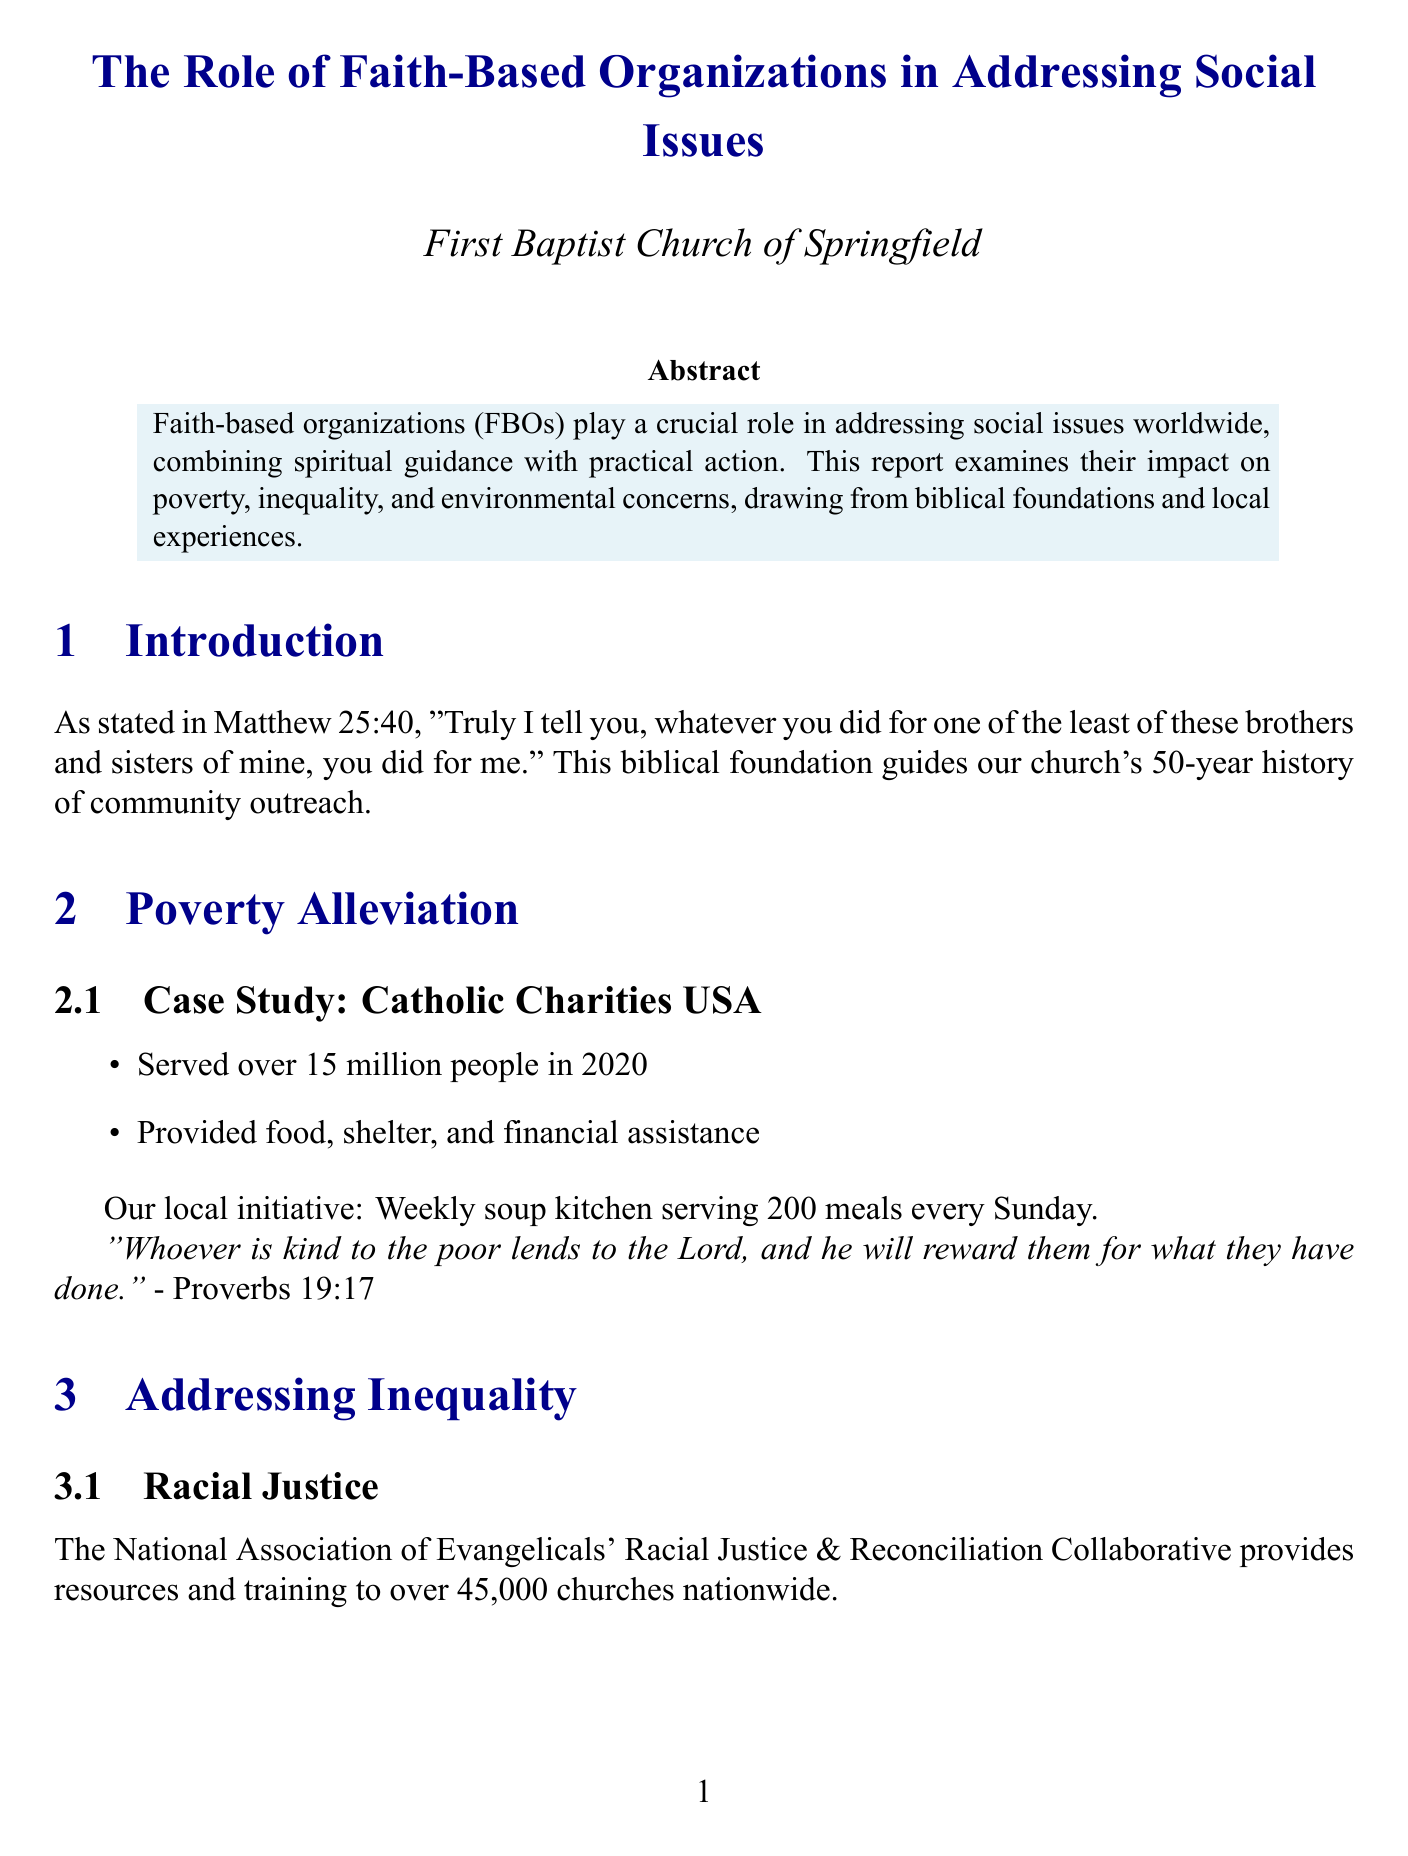What is the biblical foundation for addressing social issues? The document quotes Matthew 25:40, emphasizing the importance of helping those in need.
Answer: Matthew 25:40 How many people did Catholic Charities USA serve in 2020? The document states that they served over 15 million people in that year.
Answer: 15 million What is the local initiative mentioned for poverty alleviation? The report describes a weekly soup kitchen that serves meals to people in the community.
Answer: Weekly soup kitchen Which organization focuses on gender equality empowerment? The document mentions World Vision and its program aimed at women and girls' education and economic opportunities.
Answer: World Vision What is the focus of A Rocha International? The document explains that A Rocha International focuses on Christian nature conservation in multiple countries.
Answer: Christian nature conservation What biblical verse is cited in relation to environmental stewardship? The document includes Genesis 2:15, highlighting the responsibility to care for the Earth.
Answer: Genesis 2:15 What topic does the section on challenges and opportunities cover? The document lists interfaith collaboration, government partnerships, and funding constraints as key challenges.
Answer: Interfaith collaboration What element is emphasized in the future directions of FBOs? The report highlights several aspects, including technology integration as a significant focus for future outreach efforts.
Answer: Technology integration What impact does the church involvement have on its congregation? The document notes that involvement in social issues has deepened the congregation's faith and sense of purpose.
Answer: Deepened faith and sense of purpose 